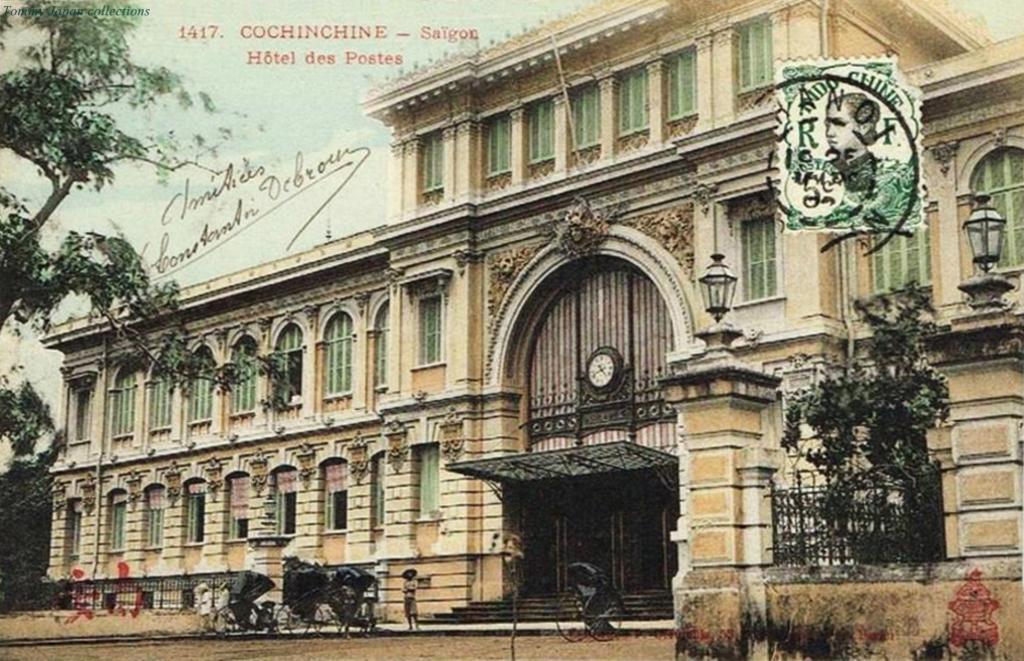How would you summarize this image in a sentence or two? In this image in the center there is a building, and at the bottom there are some vehicles and one person is standing. And he is wearing a hat and in the center of the building there is one clock and some lights railing, trees. And on the right side of the mage there is one stamp, and on the left side there is text. At the bottom there is road. 